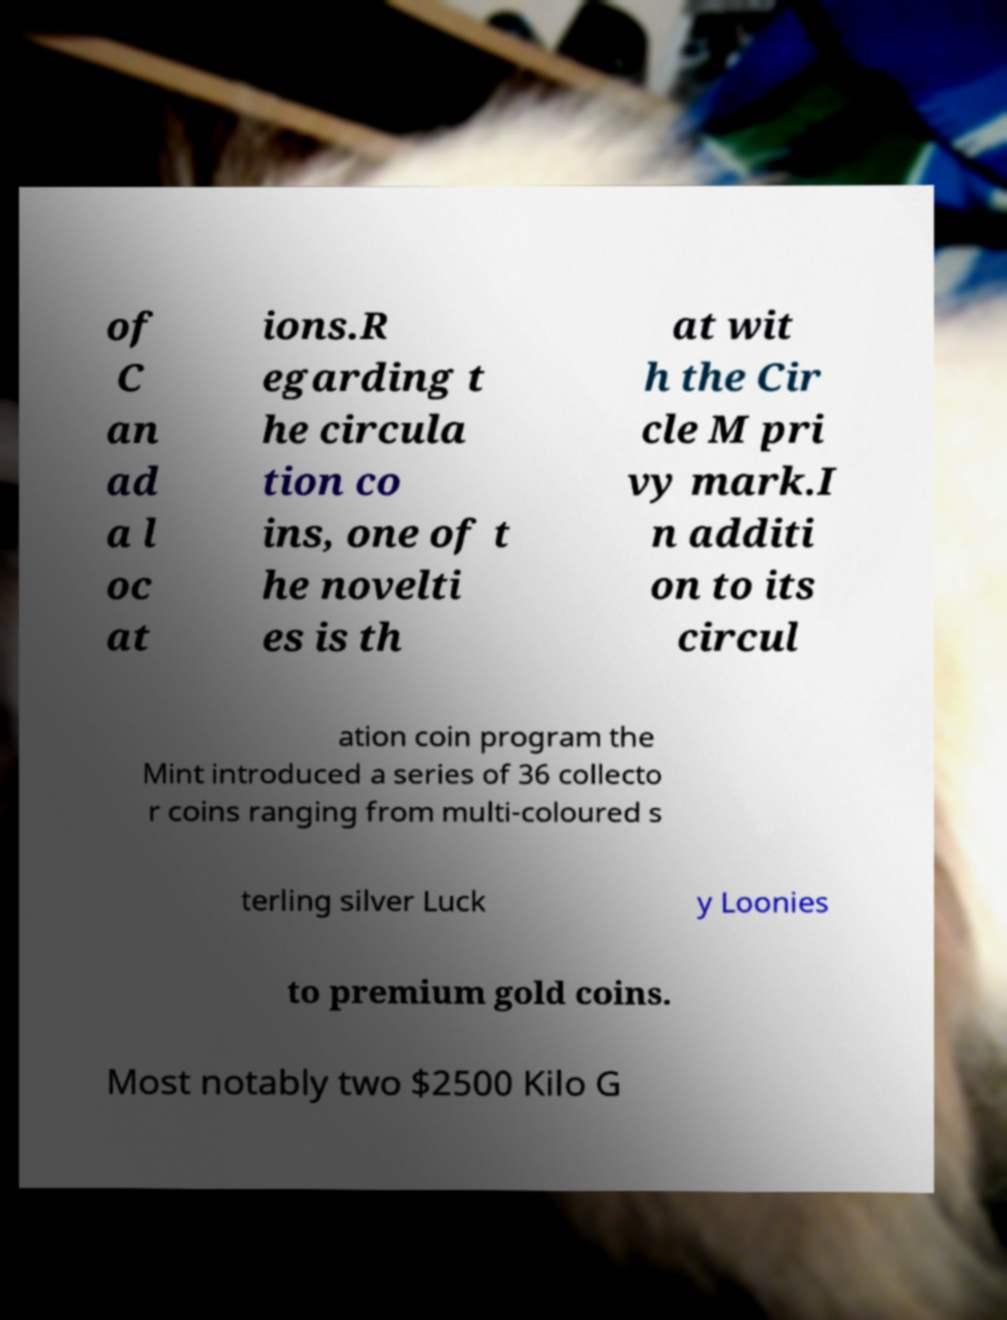Can you read and provide the text displayed in the image?This photo seems to have some interesting text. Can you extract and type it out for me? of C an ad a l oc at ions.R egarding t he circula tion co ins, one of t he novelti es is th at wit h the Cir cle M pri vy mark.I n additi on to its circul ation coin program the Mint introduced a series of 36 collecto r coins ranging from multi-coloured s terling silver Luck y Loonies to premium gold coins. Most notably two $2500 Kilo G 